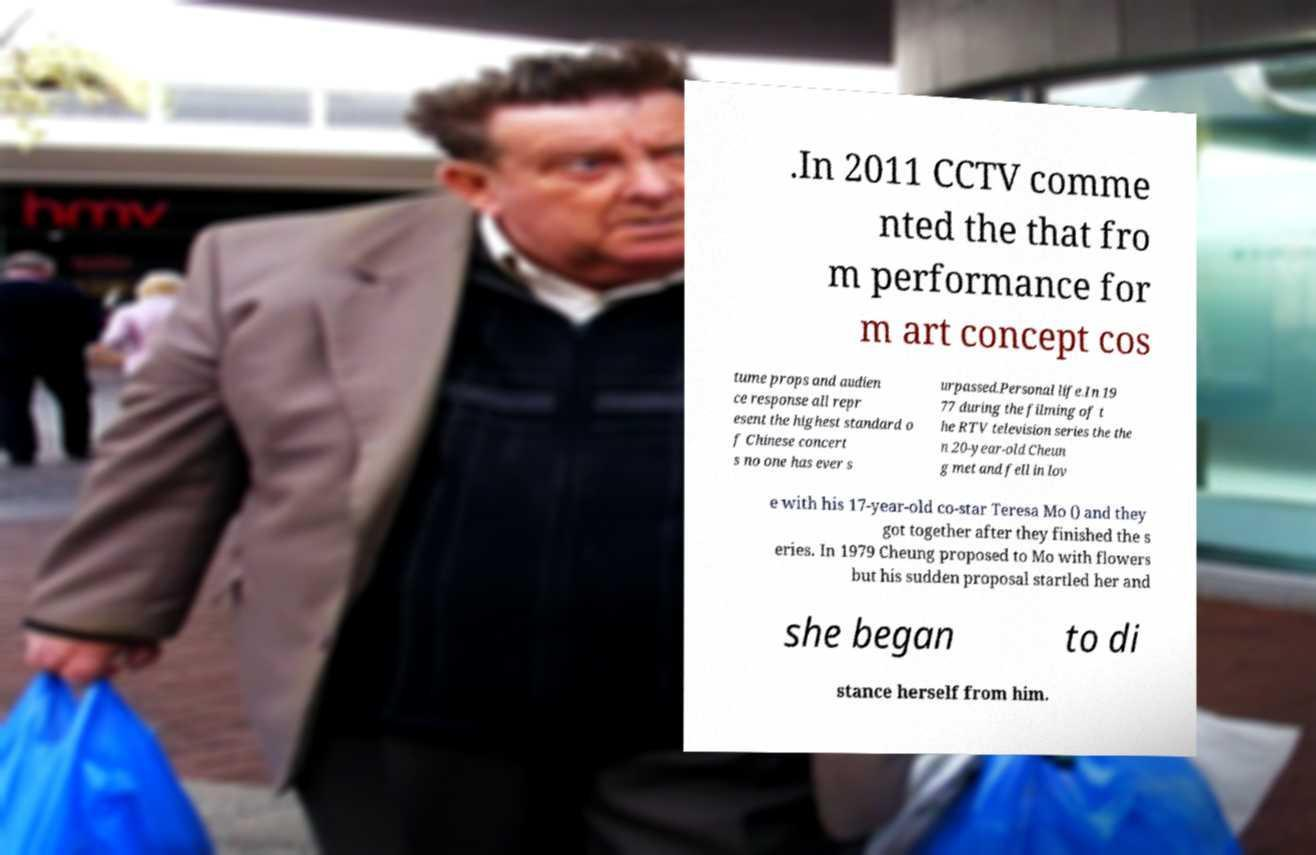For documentation purposes, I need the text within this image transcribed. Could you provide that? .In 2011 CCTV comme nted the that fro m performance for m art concept cos tume props and audien ce response all repr esent the highest standard o f Chinese concert s no one has ever s urpassed.Personal life.In 19 77 during the filming of t he RTV television series the the n 20-year-old Cheun g met and fell in lov e with his 17-year-old co-star Teresa Mo () and they got together after they finished the s eries. In 1979 Cheung proposed to Mo with flowers but his sudden proposal startled her and she began to di stance herself from him. 